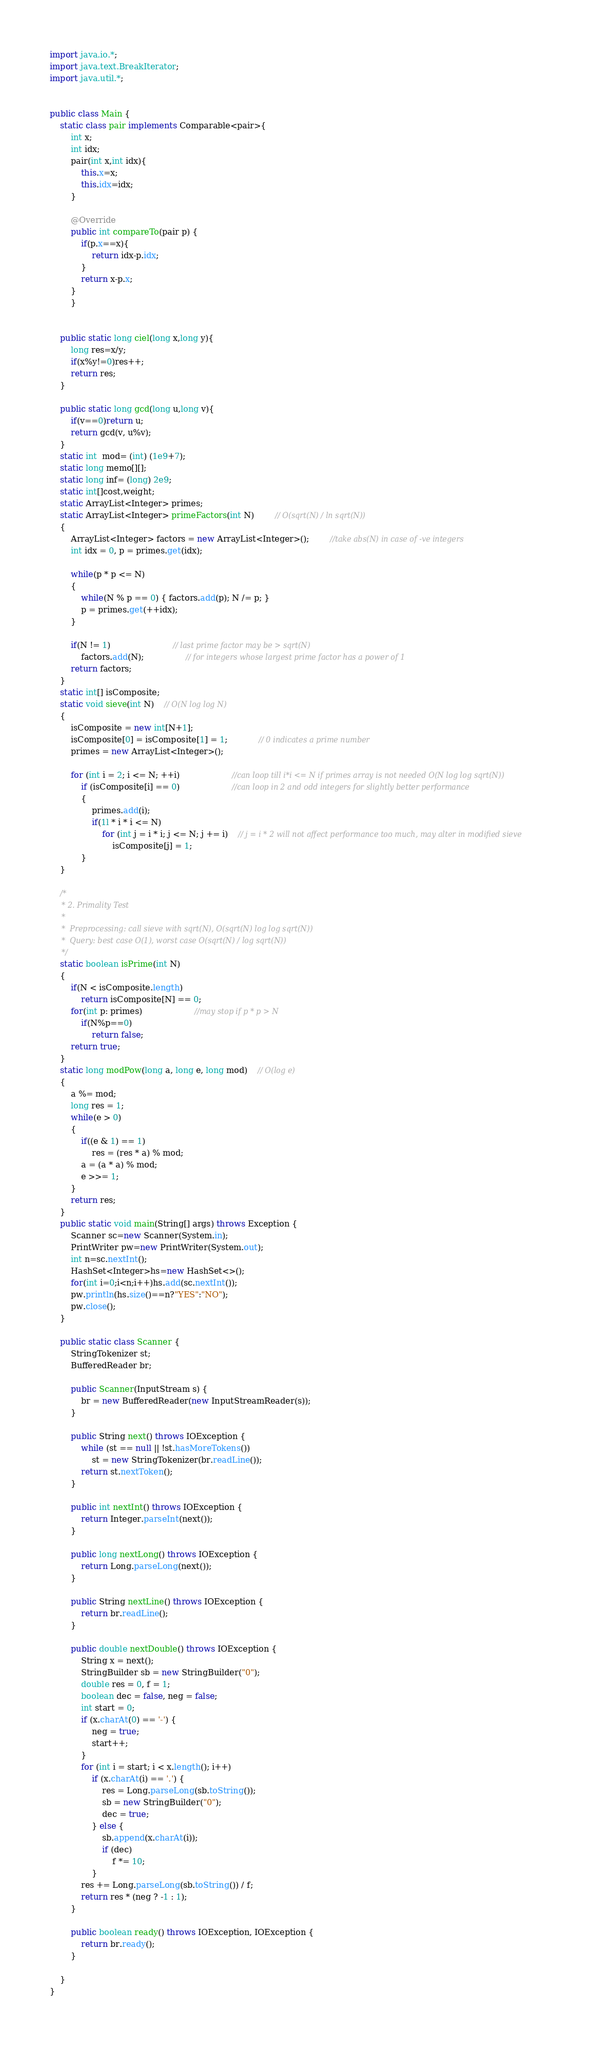<code> <loc_0><loc_0><loc_500><loc_500><_Java_>


import java.io.*;
import java.text.BreakIterator;
import java.util.*;


public class Main {
    static class pair implements Comparable<pair>{
        int x;
        int idx;
        pair(int x,int idx){
            this.x=x;
            this.idx=idx;
        }

        @Override
        public int compareTo(pair p) {
            if(p.x==x){
                return idx-p.idx;
            }
            return x-p.x;
        }
        }


    public static long ciel(long x,long y){
        long res=x/y;
        if(x%y!=0)res++;
        return res;
    }

    public static long gcd(long u,long v){
        if(v==0)return u;
        return gcd(v, u%v);
    }
    static int  mod= (int) (1e9+7);
    static long memo[][];
    static long inf= (long) 2e9;
    static int[]cost,weight;
    static ArrayList<Integer> primes;
    static ArrayList<Integer> primeFactors(int N)		// O(sqrt(N) / ln sqrt(N))
    {
        ArrayList<Integer> factors = new ArrayList<Integer>();		//take abs(N) in case of -ve integers
        int idx = 0, p = primes.get(idx);

        while(p * p <= N)
        {
            while(N % p == 0) { factors.add(p); N /= p; }
            p = primes.get(++idx);
        }

        if(N != 1)						// last prime factor may be > sqrt(N)
            factors.add(N);				// for integers whose largest prime factor has a power of 1
        return factors;
    }
    static int[] isComposite;
    static void sieve(int N)	// O(N log log N)
    {
        isComposite = new int[N+1];
        isComposite[0] = isComposite[1] = 1;			// 0 indicates a prime number
        primes = new ArrayList<Integer>();

        for (int i = 2; i <= N; ++i) 					//can loop till i*i <= N if primes array is not needed O(N log log sqrt(N))
            if (isComposite[i] == 0) 					//can loop in 2 and odd integers for slightly better performance
            {
                primes.add(i);
                if(1l * i * i <= N)
                    for (int j = i * i; j <= N; j += i)	// j = i * 2 will not affect performance too much, may alter in modified sieve
                        isComposite[j] = 1;
            }
    }

    /*
     * 2. Primality Test
     *
     *  Preprocessing: call sieve with sqrt(N), O(sqrt(N) log log sqrt(N))
     *  Query: best case O(1), worst case O(sqrt(N) / log sqrt(N))
     */
    static boolean isPrime(int N)
    {
        if(N < isComposite.length)
            return isComposite[N] == 0;
        for(int p: primes)					//may stop if p * p > N
            if(N%p==0)
                return false;
        return true;
    }
    static long modPow(long a, long e, long mod)	// O(log e)
    {
        a %= mod;
        long res = 1;
        while(e > 0)
        {
            if((e & 1) == 1)
                res = (res * a) % mod;
            a = (a * a) % mod;
            e >>= 1;
        }
        return res;
    }
    public static void main(String[] args) throws Exception {
        Scanner sc=new Scanner(System.in);
        PrintWriter pw=new PrintWriter(System.out);
        int n=sc.nextInt();
        HashSet<Integer>hs=new HashSet<>();
        for(int i=0;i<n;i++)hs.add(sc.nextInt());
        pw.println(hs.size()==n?"YES":"NO");
        pw.close();
    }

    public static class Scanner {
        StringTokenizer st;
        BufferedReader br;

        public Scanner(InputStream s) {
            br = new BufferedReader(new InputStreamReader(s));
        }

        public String next() throws IOException {
            while (st == null || !st.hasMoreTokens())
                st = new StringTokenizer(br.readLine());
            return st.nextToken();
        }

        public int nextInt() throws IOException {
            return Integer.parseInt(next());
        }

        public long nextLong() throws IOException {
            return Long.parseLong(next());
        }

        public String nextLine() throws IOException {
            return br.readLine();
        }

        public double nextDouble() throws IOException {
            String x = next();
            StringBuilder sb = new StringBuilder("0");
            double res = 0, f = 1;
            boolean dec = false, neg = false;
            int start = 0;
            if (x.charAt(0) == '-') {
                neg = true;
                start++;
            }
            for (int i = start; i < x.length(); i++)
                if (x.charAt(i) == '.') {
                    res = Long.parseLong(sb.toString());
                    sb = new StringBuilder("0");
                    dec = true;
                } else {
                    sb.append(x.charAt(i));
                    if (dec)
                        f *= 10;
                }
            res += Long.parseLong(sb.toString()) / f;
            return res * (neg ? -1 : 1);
        }

        public boolean ready() throws IOException, IOException {
            return br.ready();
        }

    }
}</code> 